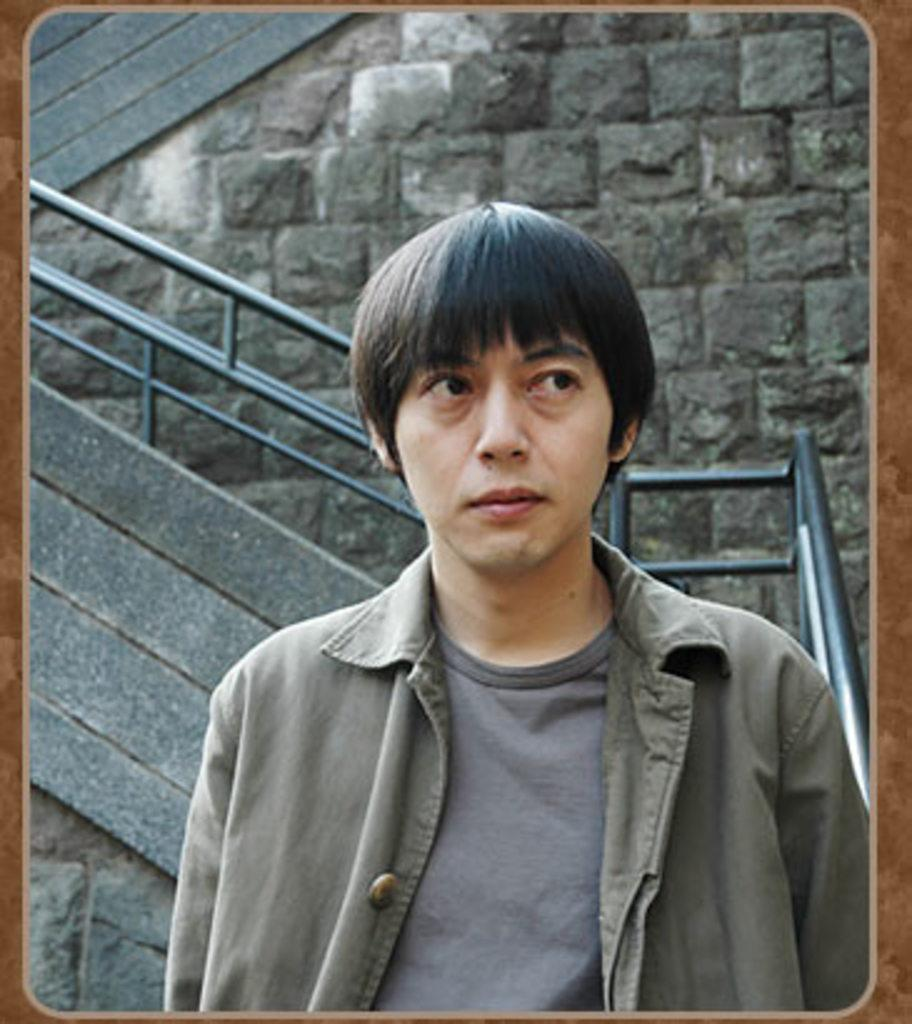What is the person in the image doing? The person is standing in the image and watching towards the right. What is located behind the person? There is fencing behind the person. What is situated behind the fencing? There is a stone wall behind the fencing. What is the person's opinion on the trade negotiations in the image? There is no information about trade negotiations or the person's opinion in the image. What does the person desire to achieve in the image? There is no information about the person's desires or goals in the image. 